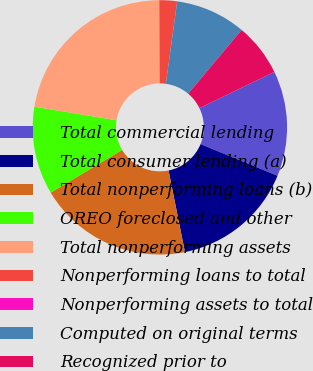<chart> <loc_0><loc_0><loc_500><loc_500><pie_chart><fcel>Total commercial lending<fcel>Total consumer lending (a)<fcel>Total nonperforming loans (b)<fcel>OREO foreclosed and other<fcel>Total nonperforming assets<fcel>Nonperforming loans to total<fcel>Nonperforming assets to total<fcel>Computed on original terms<fcel>Recognized prior to<nl><fcel>13.4%<fcel>15.63%<fcel>19.58%<fcel>11.17%<fcel>22.33%<fcel>2.24%<fcel>0.01%<fcel>8.94%<fcel>6.7%<nl></chart> 